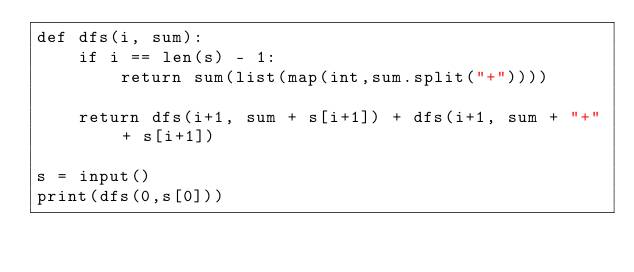<code> <loc_0><loc_0><loc_500><loc_500><_Python_>def dfs(i, sum):
    if i == len(s) - 1:
        return sum(list(map(int,sum.split("+"))))

    return dfs(i+1, sum + s[i+1]) + dfs(i+1, sum + "+" + s[i+1])

s = input()
print(dfs(0,s[0]))</code> 